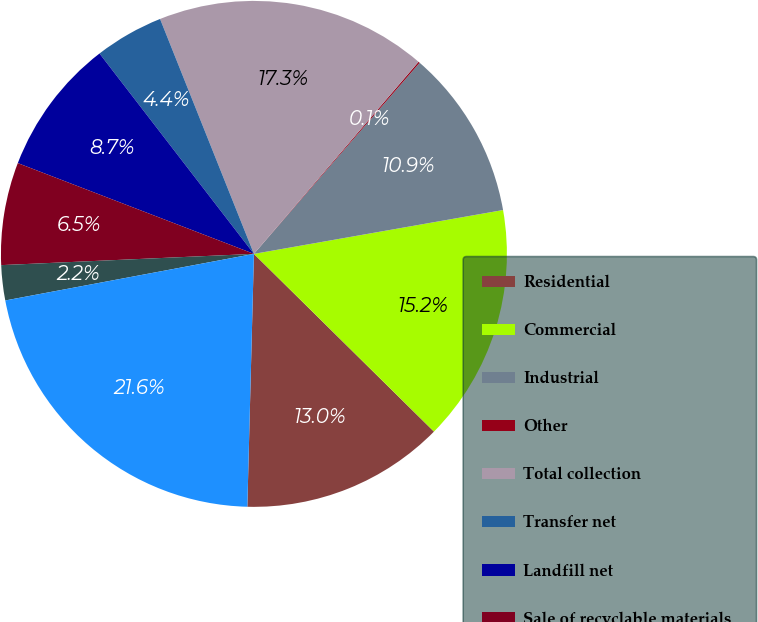<chart> <loc_0><loc_0><loc_500><loc_500><pie_chart><fcel>Residential<fcel>Commercial<fcel>Industrial<fcel>Other<fcel>Total collection<fcel>Transfer net<fcel>Landfill net<fcel>Sale of recyclable materials<fcel>Other non-core<fcel>Total revenue<nl><fcel>13.02%<fcel>15.17%<fcel>10.86%<fcel>0.09%<fcel>17.33%<fcel>4.4%<fcel>8.71%<fcel>6.55%<fcel>2.24%<fcel>21.64%<nl></chart> 